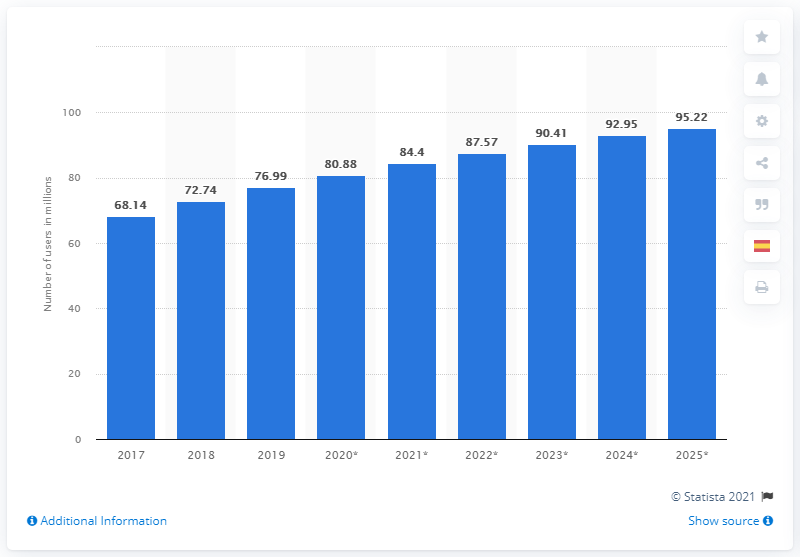Specify some key components in this picture. In 2019, 76.99% of the population in Mexico used social media. By 2025, it is projected that there will be approximately 95.22 million social media users in Mexico. 